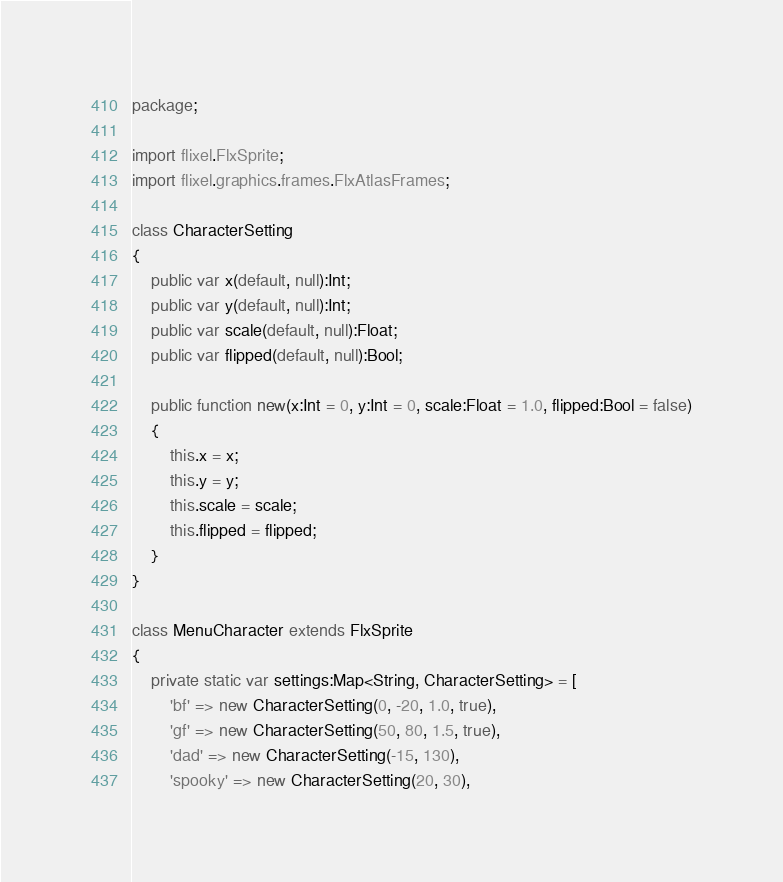<code> <loc_0><loc_0><loc_500><loc_500><_Haxe_>package;

import flixel.FlxSprite;
import flixel.graphics.frames.FlxAtlasFrames;

class CharacterSetting
{
	public var x(default, null):Int;
	public var y(default, null):Int;
	public var scale(default, null):Float;
	public var flipped(default, null):Bool;

	public function new(x:Int = 0, y:Int = 0, scale:Float = 1.0, flipped:Bool = false)
	{
		this.x = x;
		this.y = y;
		this.scale = scale;
		this.flipped = flipped;
	}
}

class MenuCharacter extends FlxSprite
{
	private static var settings:Map<String, CharacterSetting> = [
		'bf' => new CharacterSetting(0, -20, 1.0, true),
		'gf' => new CharacterSetting(50, 80, 1.5, true),
		'dad' => new CharacterSetting(-15, 130),
		'spooky' => new CharacterSetting(20, 30),</code> 